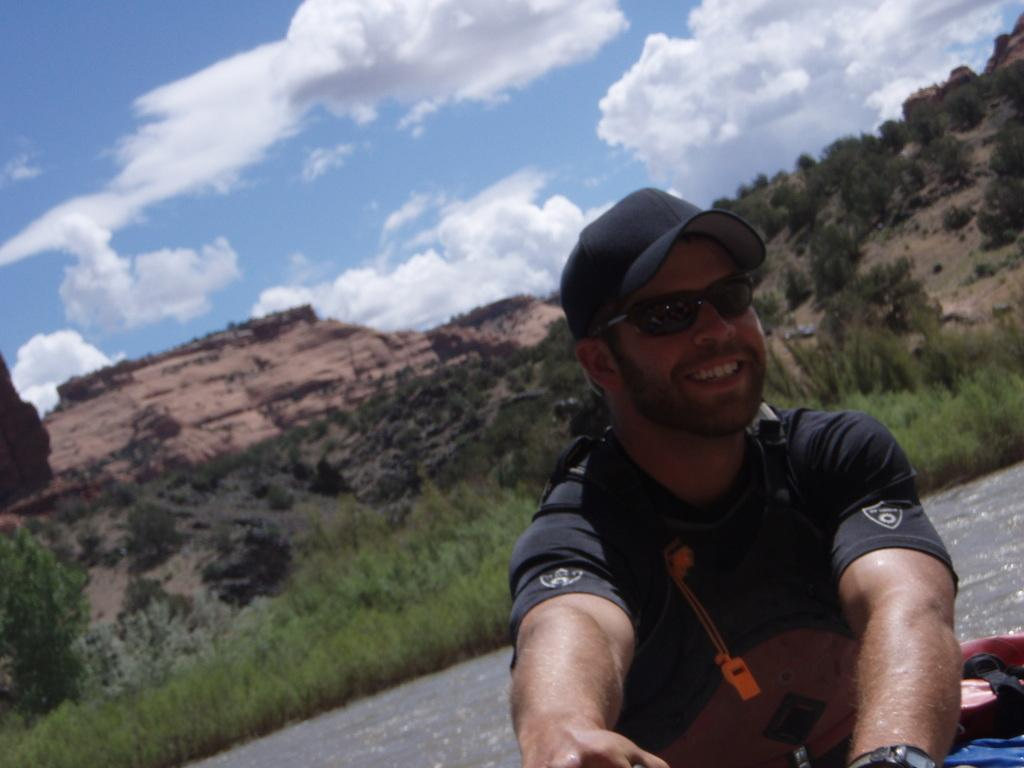What type of natural elements can be seen in the image? There are trees and plants in the image. Can you describe the person in the image? There is a person in the image. What body of water is present in the image? There is a river at the bottom of the image. What geographical feature is located in the middle of the image? There is a hill in the middle of the image. What can be seen in the sky in the image? There are clouds in the sky. What type of gift did the person receive for their aunt's birthday in the image? There is no gift, aunt, or birthday mentioned or depicted in the image. 